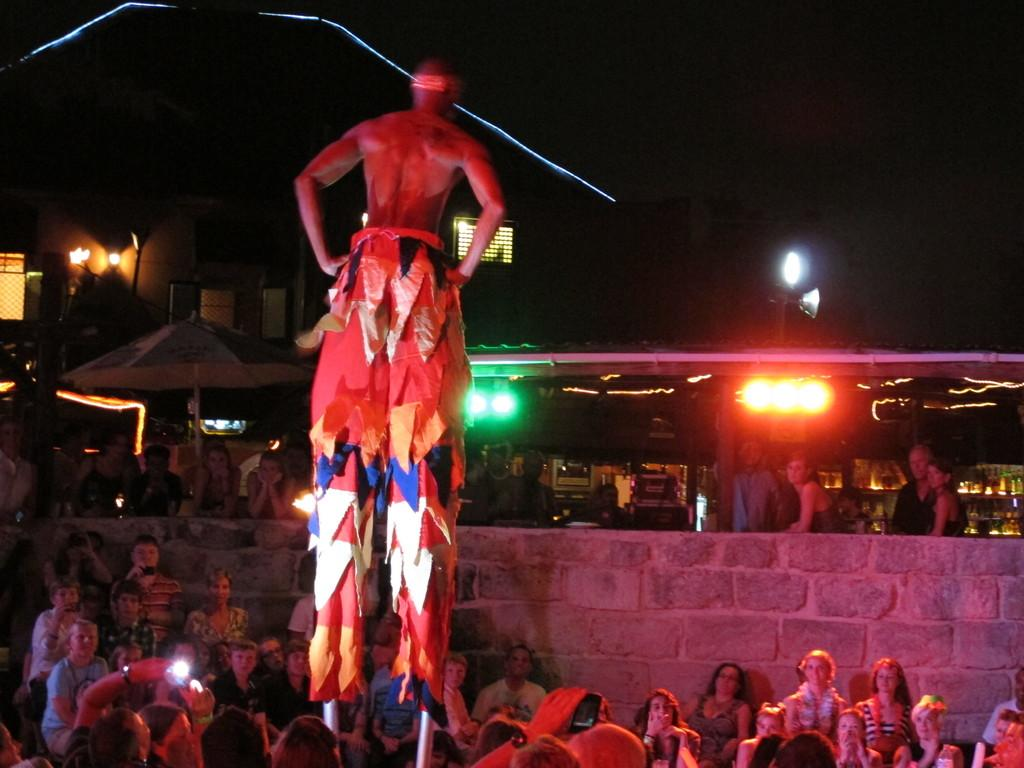How many people are in the image? There is a group of people in the image. What can be seen illuminated in the image? There are lights visible in the image. What type of structures are present in the image? There are buildings in the image. What object is used for protection from the elements in the image? There is an umbrella in the image. What is the color of the background in the image? The background of the image is dark. Can you see any quicksand in the image? There is no quicksand present in the image. What type of reaction is the group of people having in the image? The image does not show any specific reactions of the people, so it cannot be determined from the image. 